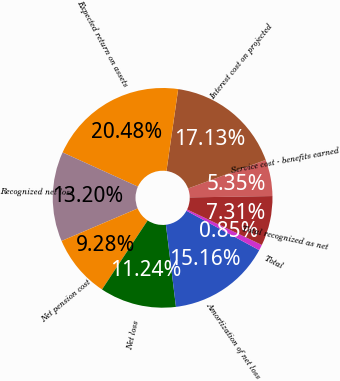<chart> <loc_0><loc_0><loc_500><loc_500><pie_chart><fcel>Service cost - benefits earned<fcel>Interest cost on projected<fcel>Expected return on assets<fcel>Recognized net loss<fcel>Net pension cost<fcel>Net loss<fcel>Amortization of net loss<fcel>Total<fcel>Total recognized as net<nl><fcel>5.35%<fcel>17.13%<fcel>20.48%<fcel>13.2%<fcel>9.28%<fcel>11.24%<fcel>15.16%<fcel>0.85%<fcel>7.31%<nl></chart> 